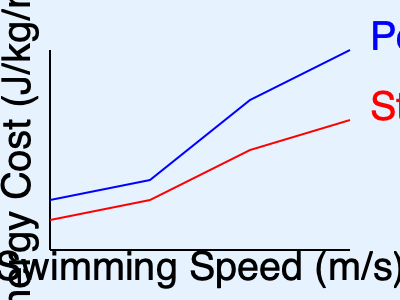Based on the graph showing energy cost versus swimming speed for two seal swimming patterns, at what approximate swimming speed (in m/s) does porpoising become more energy-efficient than steady swimming? To determine when porpoising becomes more energy-efficient than steady swimming, we need to follow these steps:

1. Understand the graph:
   - The x-axis represents swimming speed in m/s
   - The y-axis represents energy cost in J/kg/m
   - The blue line represents porpoising
   - The red line represents steady swimming

2. Identify the intersection point:
   - The point where the blue line (porpoising) crosses below the red line (steady swimming) is where porpoising becomes more energy-efficient

3. Estimate the speed at the intersection:
   - The lines appear to intersect at approximately 2/3 of the way between the second and third tick marks on the x-axis
   - Assuming the x-axis is divided into 4 equal parts from 0 to 4 m/s, each segment represents 1 m/s
   - The intersection occurs at about 2.3 m/s

4. Interpret the result:
   - At speeds lower than 2.3 m/s, steady swimming is more energy-efficient
   - At speeds higher than 2.3 m/s, porpoising is more energy-efficient

Therefore, porpoising becomes more energy-efficient than steady swimming at approximately 2.3 m/s.
Answer: Approximately 2.3 m/s 